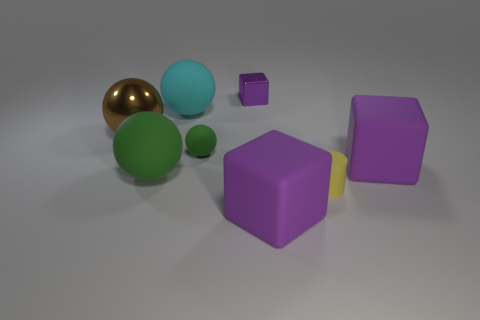Do the cyan rubber sphere and the block on the right side of the rubber cylinder have the same size?
Your answer should be very brief. Yes. Is the number of large brown metallic objects in front of the small green rubber object the same as the number of large purple cubes to the right of the brown sphere?
Make the answer very short. No. What shape is the matte object that is the same color as the tiny ball?
Ensure brevity in your answer.  Sphere. There is a large purple object that is in front of the yellow matte object; what is its material?
Your response must be concise. Rubber. Do the yellow rubber cylinder and the cyan thing have the same size?
Ensure brevity in your answer.  No. Is the number of tiny green rubber spheres behind the tiny purple shiny thing greater than the number of green matte blocks?
Offer a very short reply. No. The cylinder that is the same material as the large green ball is what size?
Your answer should be very brief. Small. There is a large brown object; are there any small purple blocks in front of it?
Keep it short and to the point. No. Does the cyan object have the same shape as the small yellow object?
Keep it short and to the point. No. How big is the metallic thing left of the big green rubber object behind the small thing that is to the right of the metal block?
Provide a short and direct response. Large. 